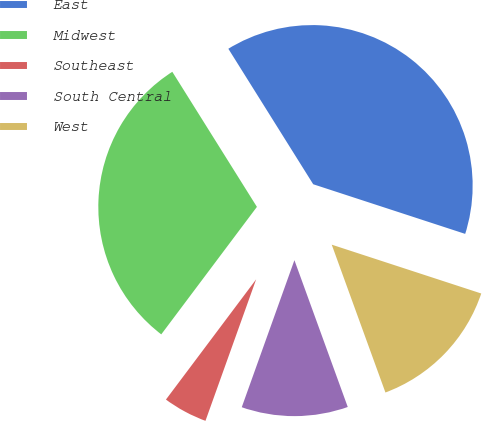Convert chart to OTSL. <chart><loc_0><loc_0><loc_500><loc_500><pie_chart><fcel>East<fcel>Midwest<fcel>Southeast<fcel>South Central<fcel>West<nl><fcel>38.93%<fcel>30.85%<fcel>4.77%<fcel>11.02%<fcel>14.43%<nl></chart> 